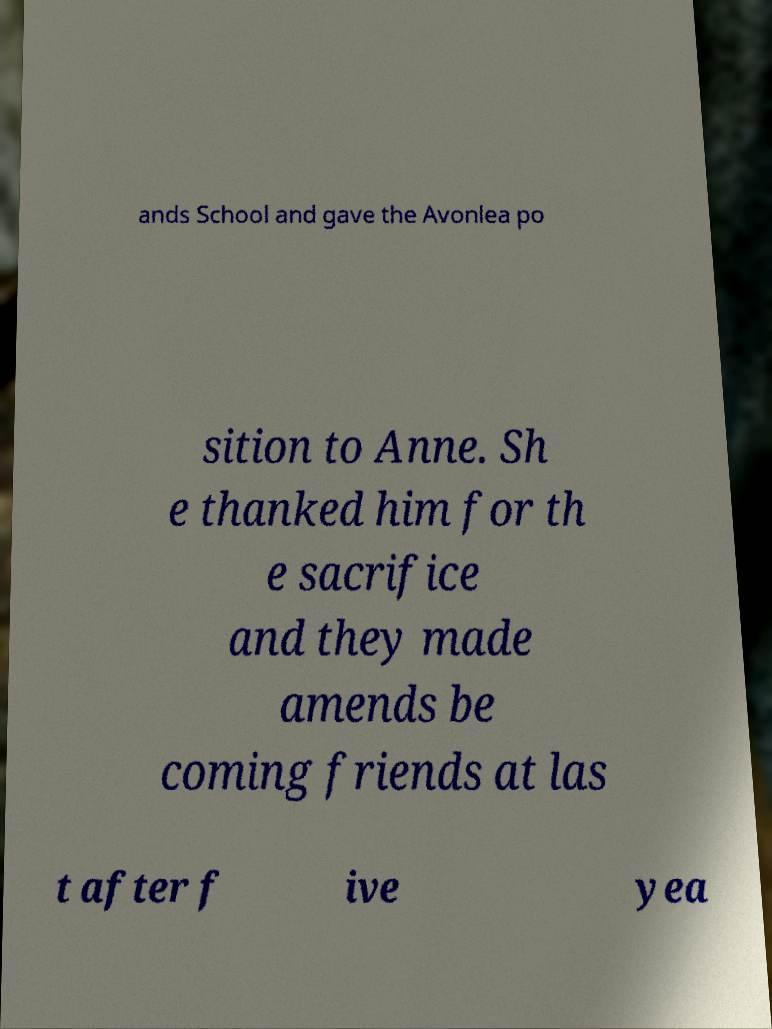There's text embedded in this image that I need extracted. Can you transcribe it verbatim? ands School and gave the Avonlea po sition to Anne. Sh e thanked him for th e sacrifice and they made amends be coming friends at las t after f ive yea 